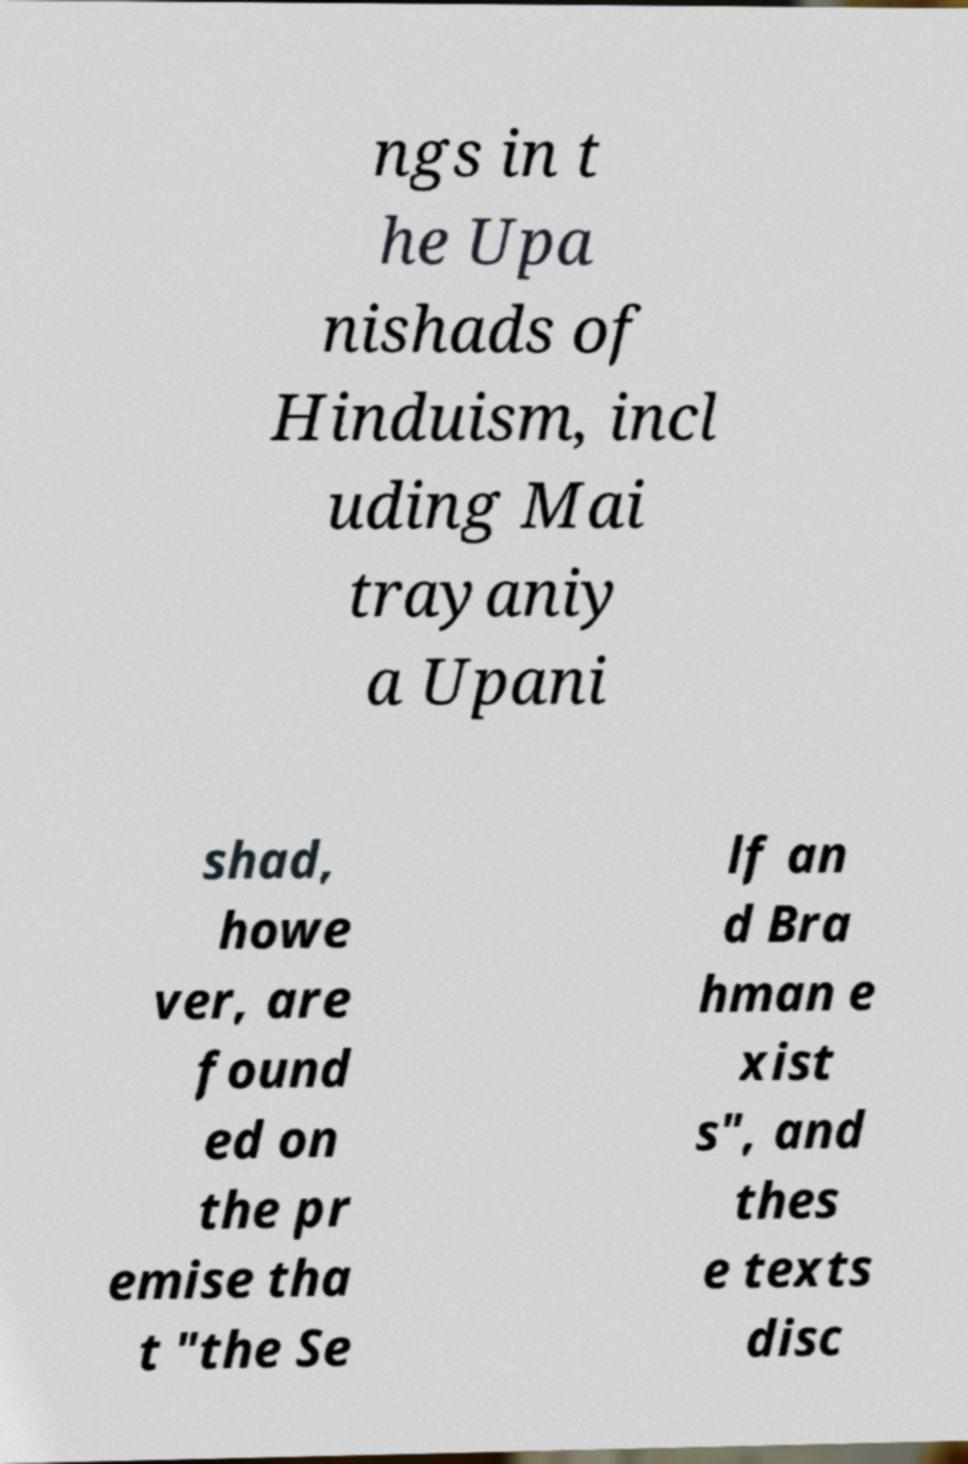Can you accurately transcribe the text from the provided image for me? ngs in t he Upa nishads of Hinduism, incl uding Mai trayaniy a Upani shad, howe ver, are found ed on the pr emise tha t "the Se lf an d Bra hman e xist s", and thes e texts disc 